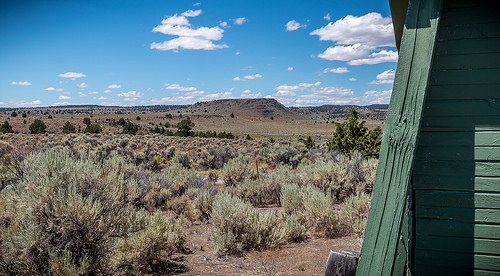<image>
Is there a cloud above the shrubbery? Yes. The cloud is positioned above the shrubbery in the vertical space, higher up in the scene. 